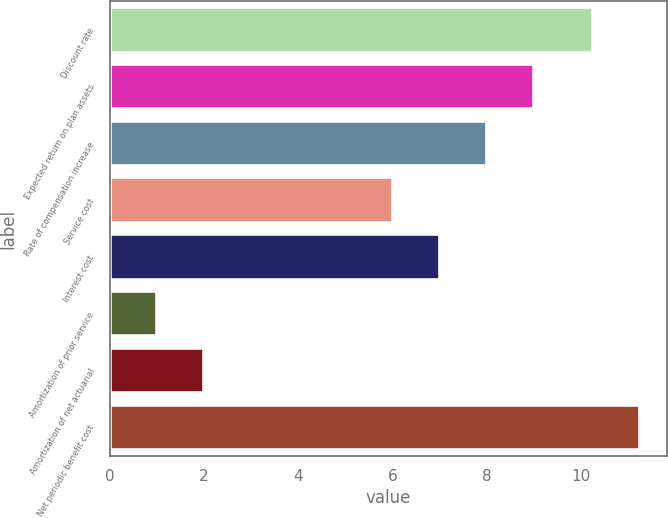Convert chart to OTSL. <chart><loc_0><loc_0><loc_500><loc_500><bar_chart><fcel>Discount rate<fcel>Expected return on plan assets<fcel>Rate of compensation increase<fcel>Service cost<fcel>Interest cost<fcel>Amortization of prior service<fcel>Amortization of net actuarial<fcel>Net periodic benefit cost<nl><fcel>10.25<fcel>9<fcel>8<fcel>6<fcel>7<fcel>1<fcel>2<fcel>11.25<nl></chart> 